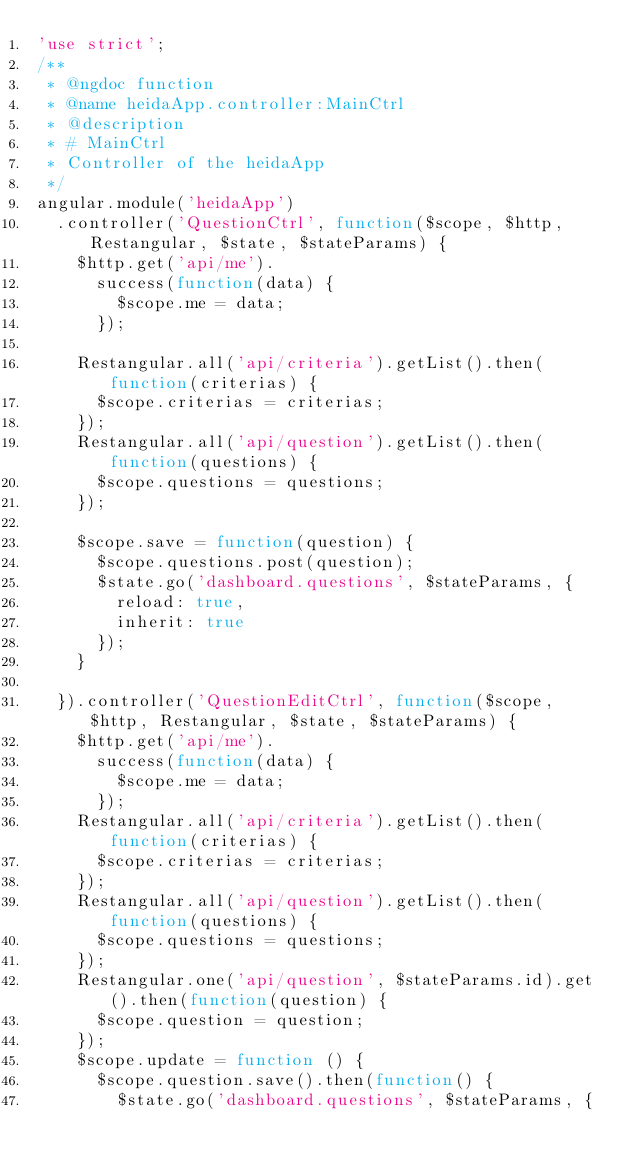Convert code to text. <code><loc_0><loc_0><loc_500><loc_500><_JavaScript_>'use strict';
/**
 * @ngdoc function
 * @name heidaApp.controller:MainCtrl
 * @description
 * # MainCtrl
 * Controller of the heidaApp
 */
angular.module('heidaApp')
  .controller('QuestionCtrl', function($scope, $http, Restangular, $state, $stateParams) {
    $http.get('api/me').
      success(function(data) {
        $scope.me = data;
      });

    Restangular.all('api/criteria').getList().then(function(criterias) {
      $scope.criterias = criterias;
    });
    Restangular.all('api/question').getList().then(function(questions) {
      $scope.questions = questions;
    });

    $scope.save = function(question) {
      $scope.questions.post(question);
      $state.go('dashboard.questions', $stateParams, {
        reload: true,
        inherit: true
      });
    }

  }).controller('QuestionEditCtrl', function($scope, $http, Restangular, $state, $stateParams) {
    $http.get('api/me').
      success(function(data) {
        $scope.me = data;
      });
    Restangular.all('api/criteria').getList().then(function(criterias) {
      $scope.criterias = criterias;
    });
    Restangular.all('api/question').getList().then(function(questions) {
      $scope.questions = questions;
    });
    Restangular.one('api/question', $stateParams.id).get().then(function(question) {
      $scope.question = question;
    });
    $scope.update = function () {
      $scope.question.save().then(function() {
        $state.go('dashboard.questions', $stateParams, {</code> 